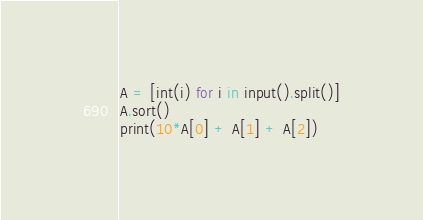<code> <loc_0><loc_0><loc_500><loc_500><_Python_>A = [int(i) for i in input().split()]
A.sort()
print(10*A[0] + A[1] + A[2])</code> 